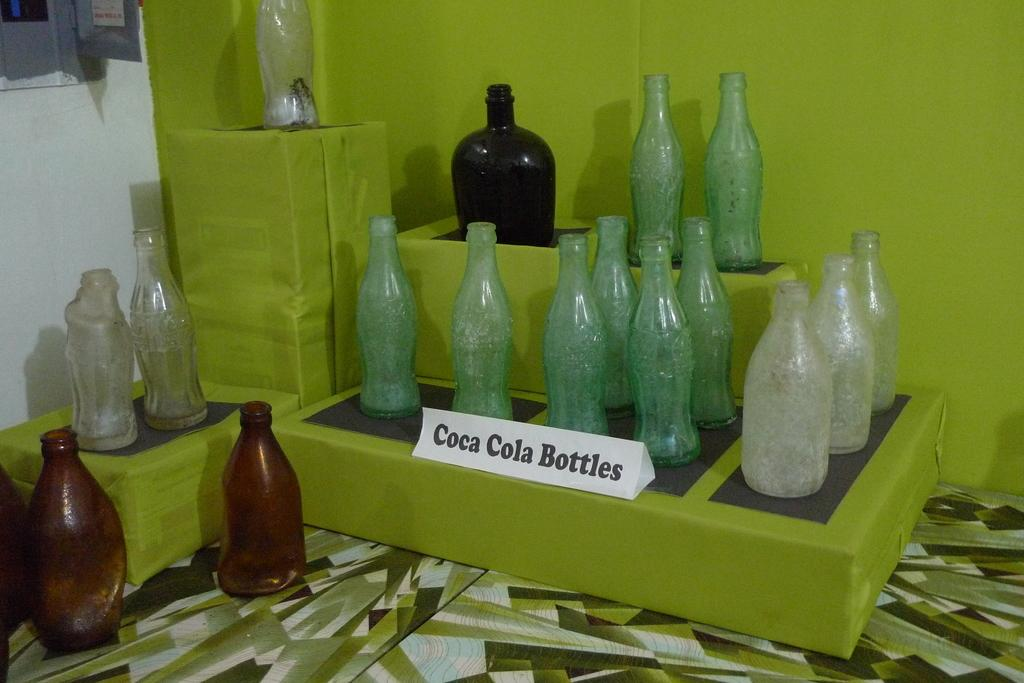<image>
Create a compact narrative representing the image presented. green stands with a display of old coca cola bottles 